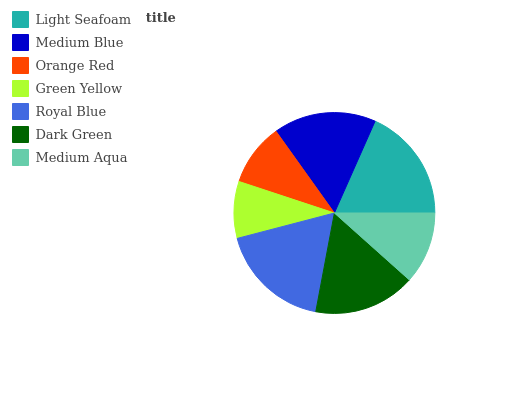Is Green Yellow the minimum?
Answer yes or no. Yes. Is Light Seafoam the maximum?
Answer yes or no. Yes. Is Medium Blue the minimum?
Answer yes or no. No. Is Medium Blue the maximum?
Answer yes or no. No. Is Light Seafoam greater than Medium Blue?
Answer yes or no. Yes. Is Medium Blue less than Light Seafoam?
Answer yes or no. Yes. Is Medium Blue greater than Light Seafoam?
Answer yes or no. No. Is Light Seafoam less than Medium Blue?
Answer yes or no. No. Is Dark Green the high median?
Answer yes or no. Yes. Is Dark Green the low median?
Answer yes or no. Yes. Is Light Seafoam the high median?
Answer yes or no. No. Is Orange Red the low median?
Answer yes or no. No. 